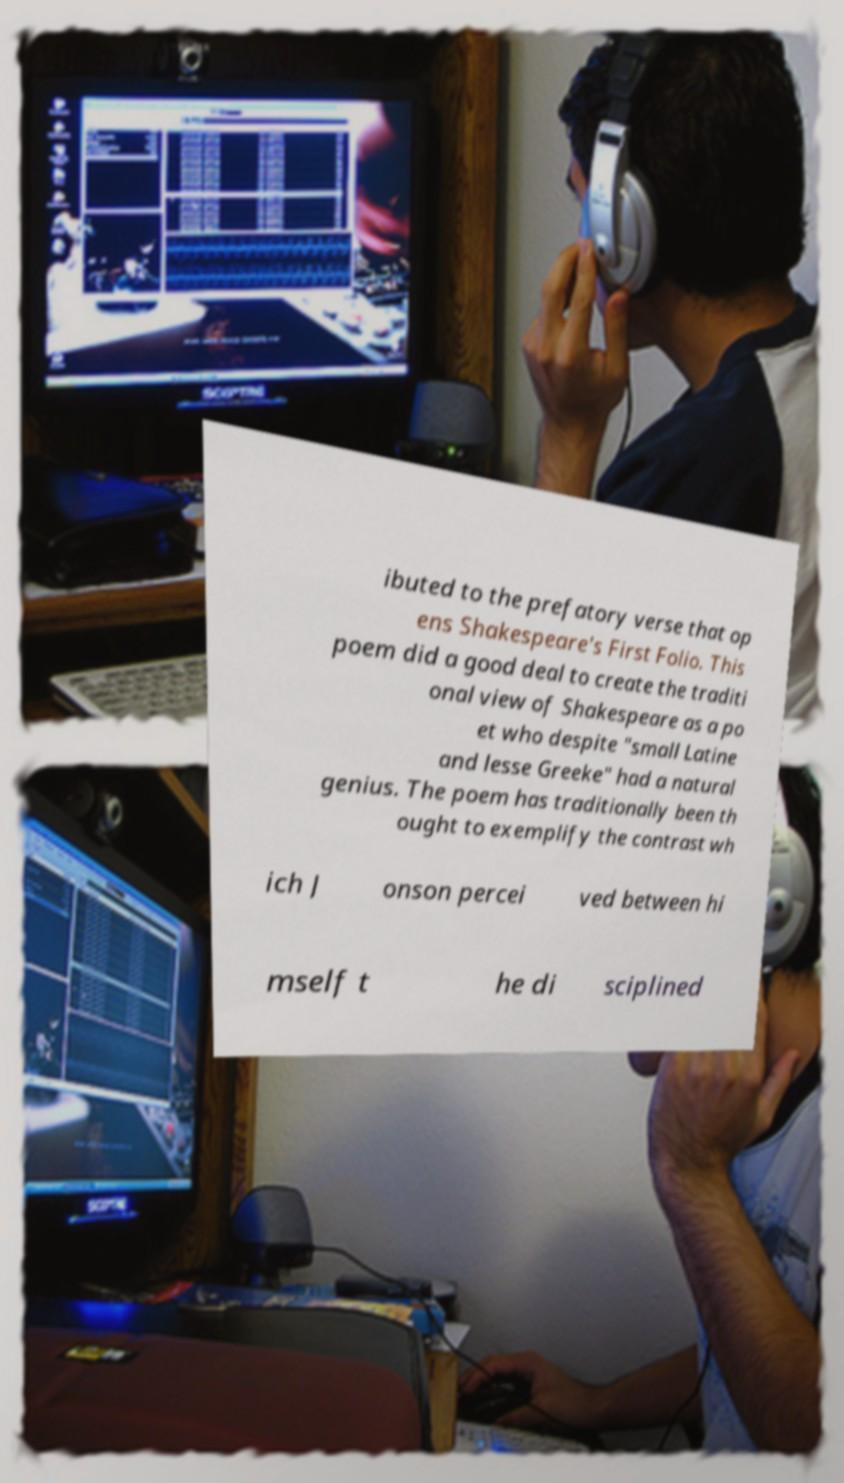I need the written content from this picture converted into text. Can you do that? ibuted to the prefatory verse that op ens Shakespeare's First Folio. This poem did a good deal to create the traditi onal view of Shakespeare as a po et who despite "small Latine and lesse Greeke" had a natural genius. The poem has traditionally been th ought to exemplify the contrast wh ich J onson percei ved between hi mself t he di sciplined 